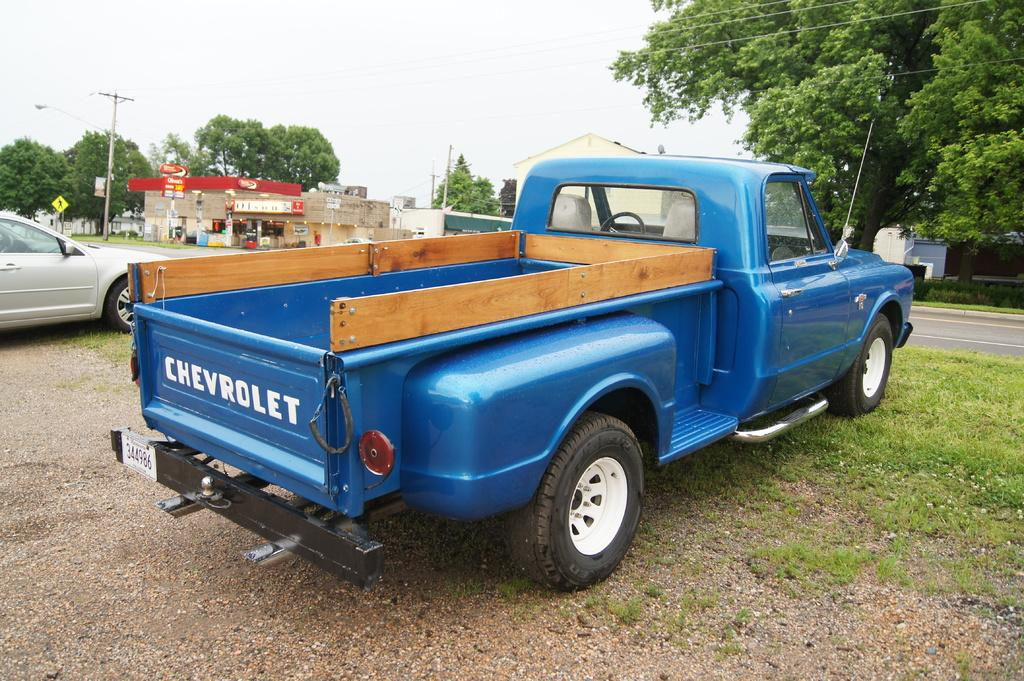What types of objects are on the ground in the image? There are vehicles on the ground in the image. What structures can be seen in the image? There are buildings in the image. What type of vegetation is present in the image? There are trees in the image. What signs are visible in the image? There are name boards in the image. What utility structures can be seen in the image? There are electric poles in the image. What other objects are present in the image? There are other objects in the image. What can be seen in the background of the image? The sky is visible in the background of the image. Can you tell me how many cherries are on the elbow of the person in the image? There is no person present in the image, and therefore no elbows or cherries can be observed. What type of move is being performed by the vehicle in the image? Vehicles do not perform moves; they are stationary objects in the image. 